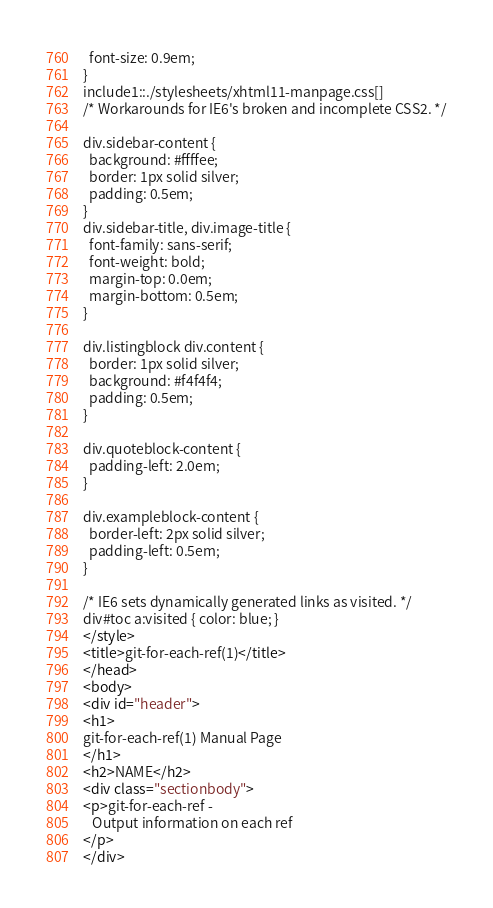Convert code to text. <code><loc_0><loc_0><loc_500><loc_500><_HTML_>  font-size: 0.9em;
}
include1::./stylesheets/xhtml11-manpage.css[]
/* Workarounds for IE6's broken and incomplete CSS2. */

div.sidebar-content {
  background: #ffffee;
  border: 1px solid silver;
  padding: 0.5em;
}
div.sidebar-title, div.image-title {
  font-family: sans-serif;
  font-weight: bold;
  margin-top: 0.0em;
  margin-bottom: 0.5em;
}

div.listingblock div.content {
  border: 1px solid silver;
  background: #f4f4f4;
  padding: 0.5em;
}

div.quoteblock-content {
  padding-left: 2.0em;
}

div.exampleblock-content {
  border-left: 2px solid silver;
  padding-left: 0.5em;
}

/* IE6 sets dynamically generated links as visited. */
div#toc a:visited { color: blue; }
</style>
<title>git-for-each-ref(1)</title>
</head>
<body>
<div id="header">
<h1>
git-for-each-ref(1) Manual Page
</h1>
<h2>NAME</h2>
<div class="sectionbody">
<p>git-for-each-ref -
   Output information on each ref
</p>
</div></code> 